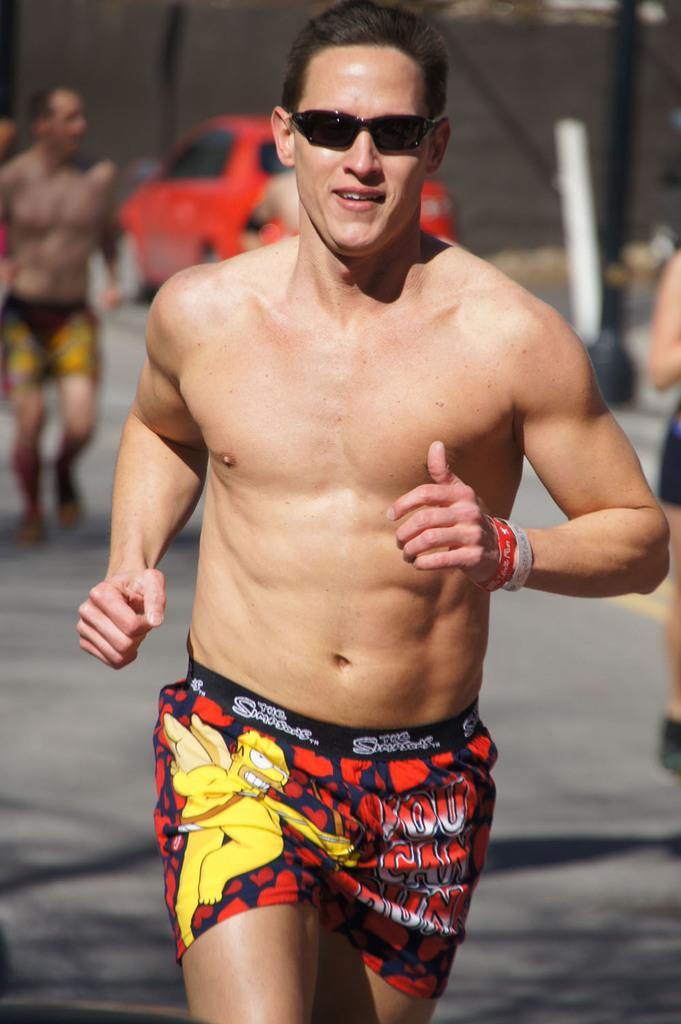What is the man in the image doing? The man is running in the image. What can be seen in the background of the image? There is a car and people in the background of the image. What objects are present in the image? There are poles in the image. What type of shade is being used by the man in the image? There is no shade present in the image; the man is running outdoors. 